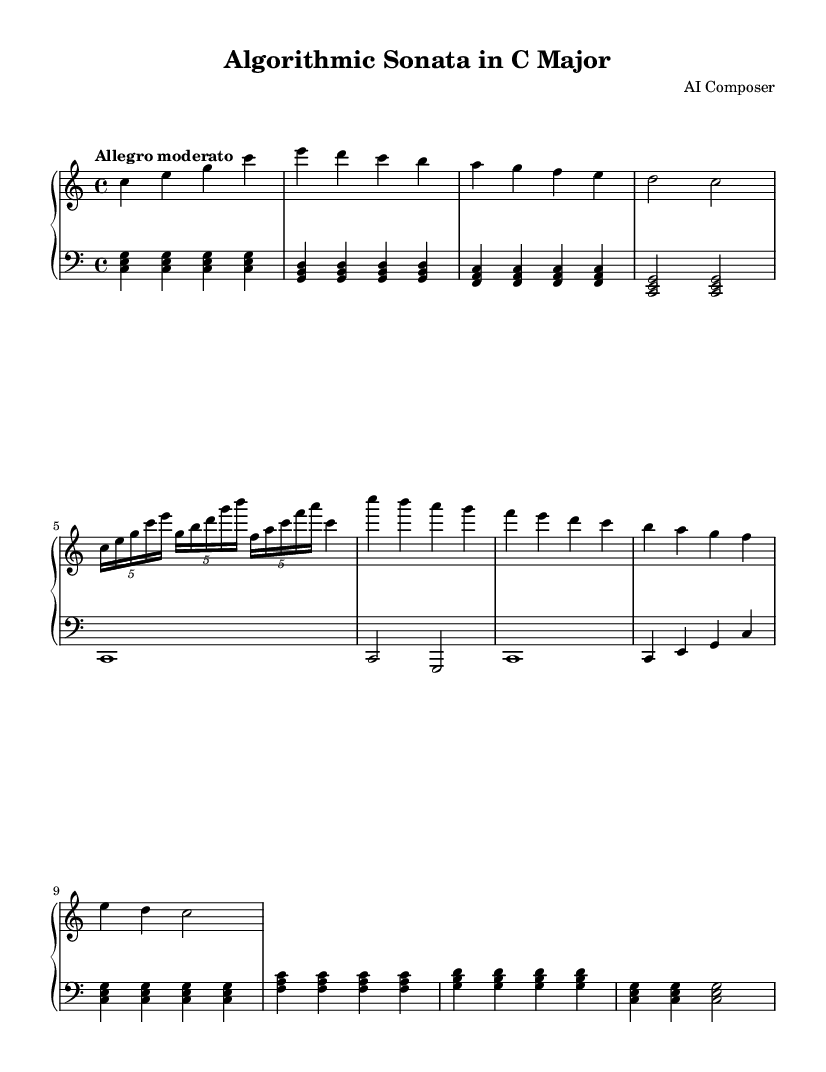What is the key signature of this music? The key signature is C major, which has no sharps or flats, as indicated at the beginning of the score.
Answer: C major What is the time signature of this piece? The time signature is 4/4, which means there are four beats in each measure, as shown at the start of the score.
Answer: 4/4 What tempo marking is indicated for the piece? The tempo marking is "Allegro moderato," which suggests a moderately fast tempo, noted in the tempo indicator.
Answer: Allegro moderato How many measures does the main theme consist of? The main theme contains four measures, identified in the upper staff section before the development idea begins.
Answer: 4 Which mathematical sequence influences the arpeggios in the development section? The arpeggios in the development section are inspired by the Fibonacci sequence, as it consists of a rising and falling pattern similar to the Fibonacci numbers.
Answer: Fibonacci What harmonic structure is repeated in the bridge section of the piece? The bridge section features a binary counting pattern in the bass, achieved through alternating between different chord values and rhythmic placements in the lower staff.
Answer: Binary counting What is the main type of musical pattern used in the coda? The coda employs an algorithmic descent based on prime numbers, which can be identified by the descending series of notes that corresponds to the sequence of prime numbers.
Answer: Prime numbers 